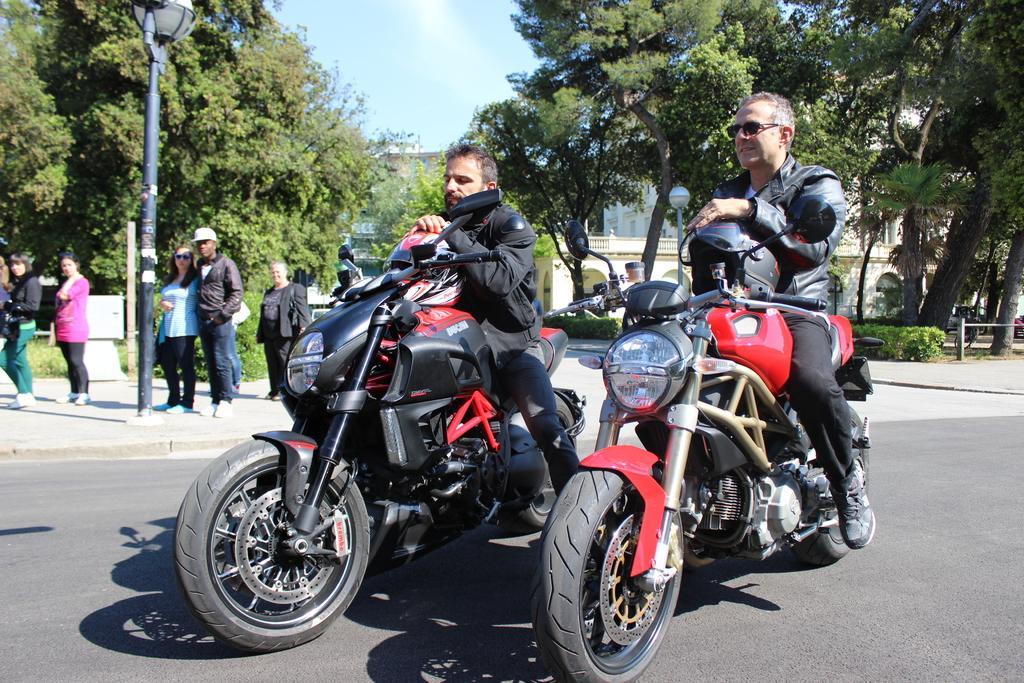Can you describe this image briefly? There are two men sitting on the bikes on the road. In the background there are some people standing. There is a street light pole here. There is a street light pole here. There are some trees and a sky here in the background. 